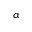<formula> <loc_0><loc_0><loc_500><loc_500>\alpha</formula> 